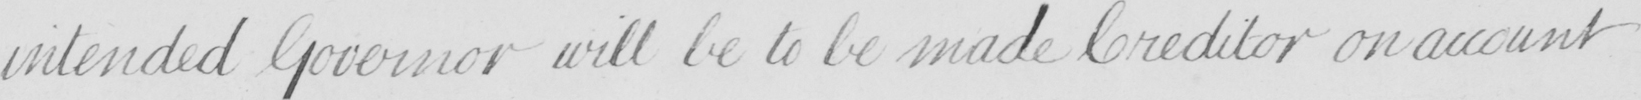What does this handwritten line say? intended Governor will be to be made Creditor on account 